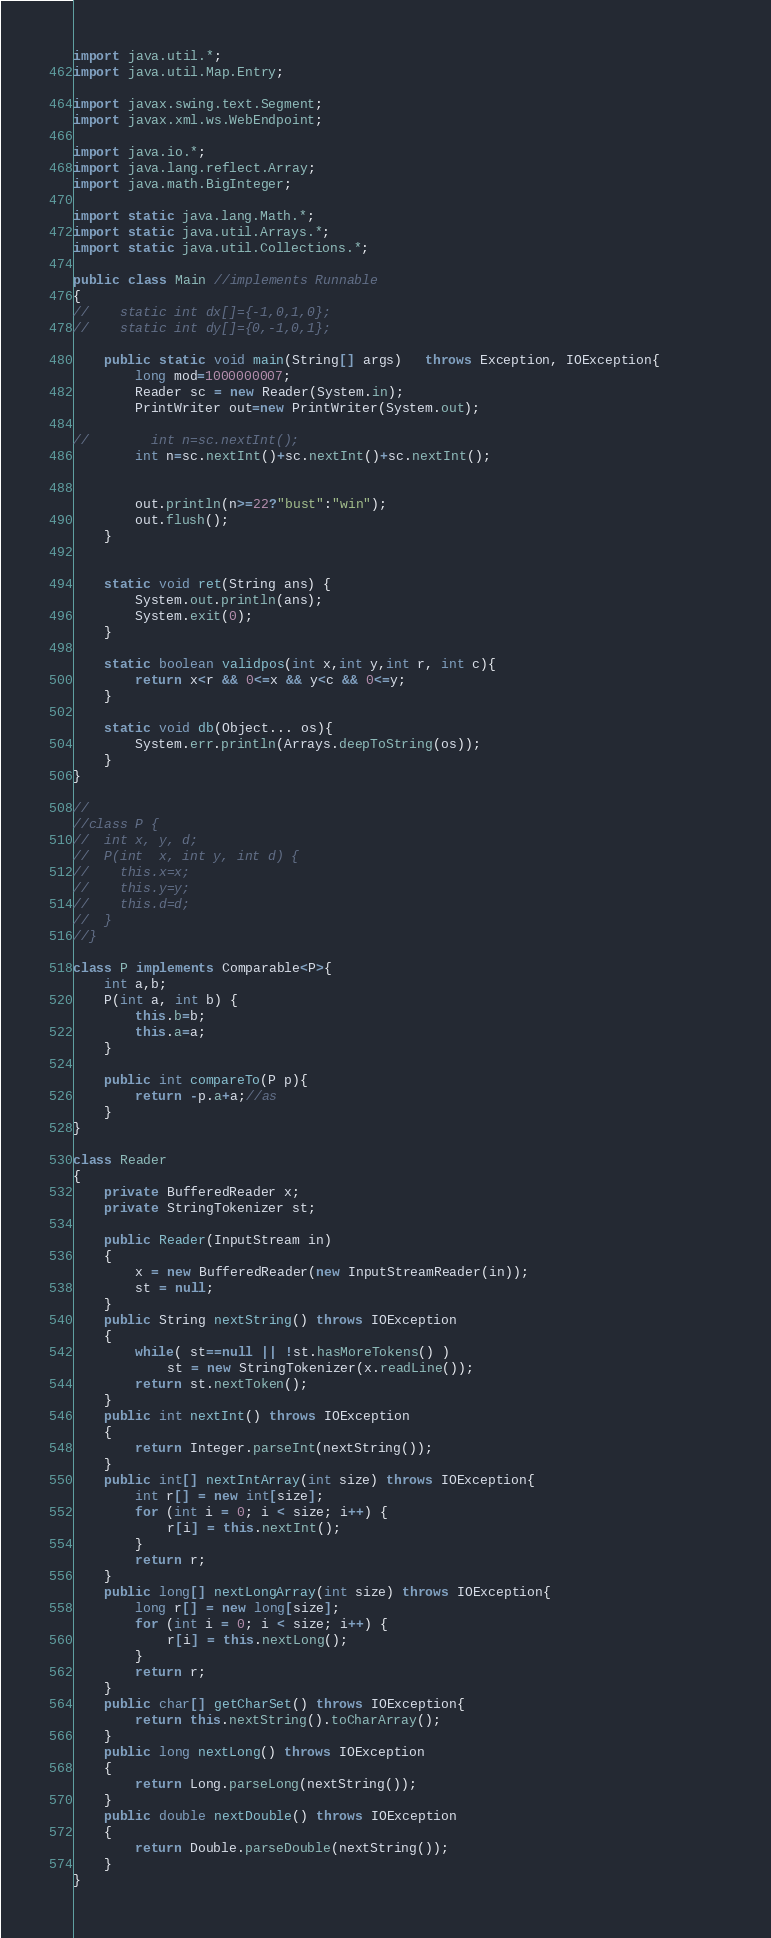Convert code to text. <code><loc_0><loc_0><loc_500><loc_500><_Java_>import java.util.*;
import java.util.Map.Entry;

import javax.swing.text.Segment;
import javax.xml.ws.WebEndpoint;

import java.io.*;
import java.lang.reflect.Array;
import java.math.BigInteger;

import static java.lang.Math.*;
import static java.util.Arrays.*;
import static java.util.Collections.*;
 
public class Main //implements Runnable
{
//    static int dx[]={-1,0,1,0};
//    static int dy[]={0,-1,0,1};
	
    public static void main(String[] args)   throws Exception, IOException{        
        long mod=1000000007;
        Reader sc = new Reader(System.in);
        PrintWriter out=new PrintWriter(System.out);

//        int n=sc.nextInt();
        int n=sc.nextInt()+sc.nextInt()+sc.nextInt();
        

        out.println(n>=22?"bust":"win");
     	out.flush();
    }


    static void ret(String ans) {
    	System.out.println(ans);
    	System.exit(0);
    }
    
    static boolean validpos(int x,int y,int r, int c){
        return x<r && 0<=x && y<c && 0<=y;
    }

    static void db(Object... os){
        System.err.println(Arrays.deepToString(os));
    }
}

//
//class P {
//	int x, y, d;
//	P(int  x, int y, int d) {
//	  this.x=x;
//	  this.y=y;
//	  this.d=d;
//	}
//}

class P implements Comparable<P>{
    int a,b;
    P(int a, int b) {
    	this.b=b;
    	this.a=a;
    }

    public int compareTo(P p){
        return -p.a+a;//as
    }
}

class Reader
{ 
    private BufferedReader x;
    private StringTokenizer st;
    
    public Reader(InputStream in)
    {
        x = new BufferedReader(new InputStreamReader(in));
        st = null;
    }
    public String nextString() throws IOException
    {
        while( st==null || !st.hasMoreTokens() )
            st = new StringTokenizer(x.readLine());
        return st.nextToken();
    }
    public int nextInt() throws IOException
    {
        return Integer.parseInt(nextString());
    }
    public int[] nextIntArray(int size) throws IOException{
        int r[] = new int[size];
        for (int i = 0; i < size; i++) {
            r[i] = this.nextInt(); 
        }
        return r;
    }
    public long[] nextLongArray(int size) throws IOException{
        long r[] = new long[size];
        for (int i = 0; i < size; i++) {
            r[i] = this.nextLong(); 
        }
        return r;
    }
    public char[] getCharSet() throws IOException{
        return this.nextString().toCharArray();
    }    
    public long nextLong() throws IOException
    {
        return Long.parseLong(nextString());
    }
    public double nextDouble() throws IOException
    {
        return Double.parseDouble(nextString());
    }
}
</code> 